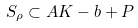Convert formula to latex. <formula><loc_0><loc_0><loc_500><loc_500>S _ { \rho } \subset A K - b + P</formula> 